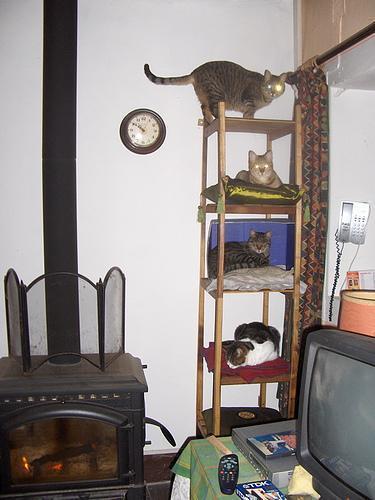How many cats?
Give a very brief answer. 4. How many cats are in the photo?
Give a very brief answer. 1. 